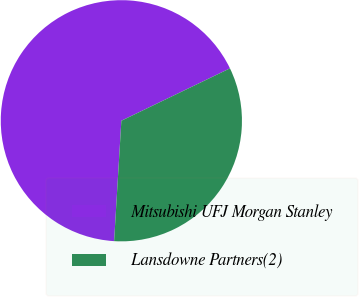Convert chart to OTSL. <chart><loc_0><loc_0><loc_500><loc_500><pie_chart><fcel>Mitsubishi UFJ Morgan Stanley<fcel>Lansdowne Partners(2)<nl><fcel>66.89%<fcel>33.11%<nl></chart> 